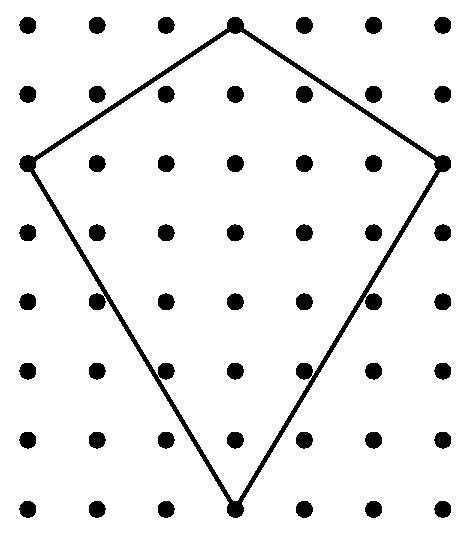What are the patterns inside the kite and do they serve a purpose? Inside the kite, there is a pattern of dots arranged in rows and columns. This pattern doesn't seem to serve a structural purpose; it's likely decorative, adding visual interest and possibly making the kite more appealing as it flies. 